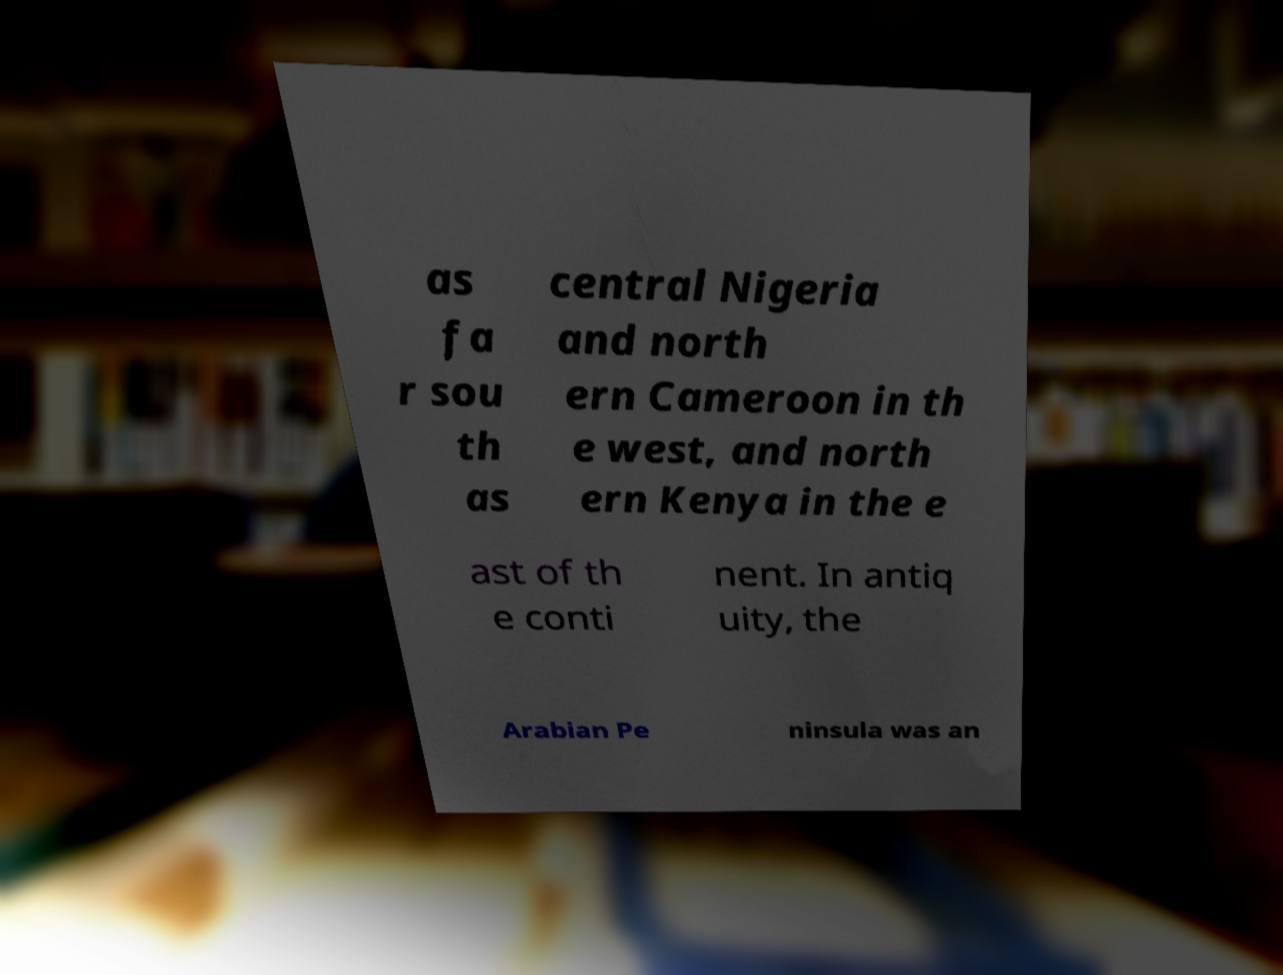Could you extract and type out the text from this image? as fa r sou th as central Nigeria and north ern Cameroon in th e west, and north ern Kenya in the e ast of th e conti nent. In antiq uity, the Arabian Pe ninsula was an 